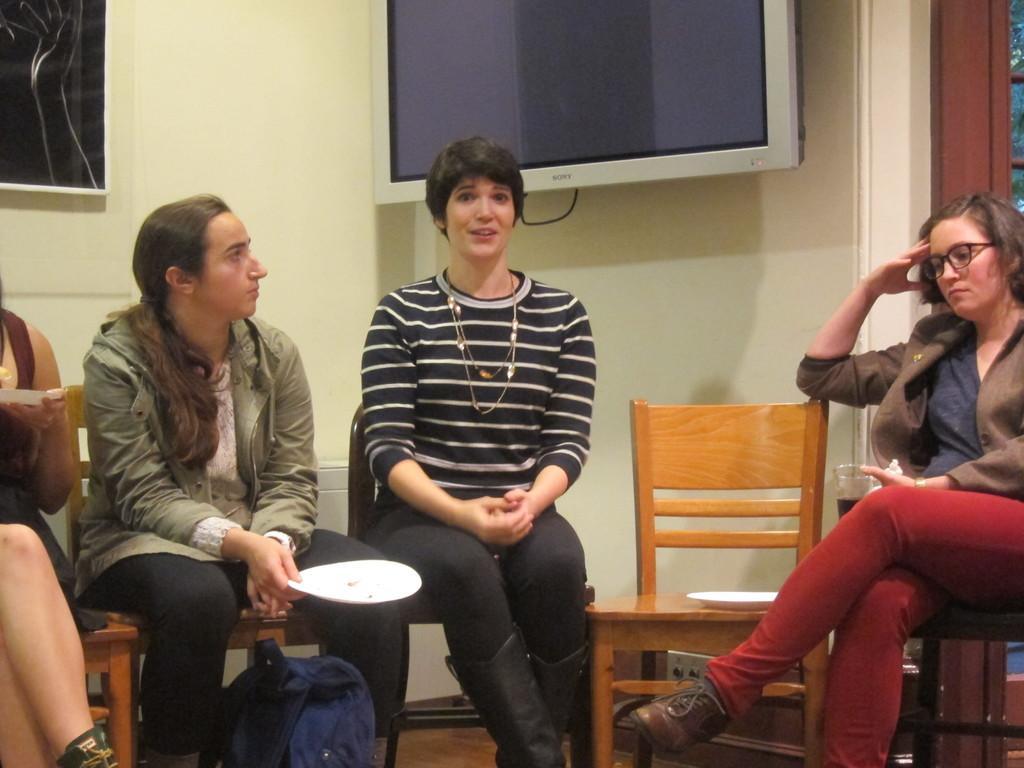How would you summarize this image in a sentence or two? In this image I see 4 women and all of them are sitting on the chairs and there is a bag over here and this woman is holding a plate and this woman is holding a glass. In the background I see the wall, a TV and a photo frame. 